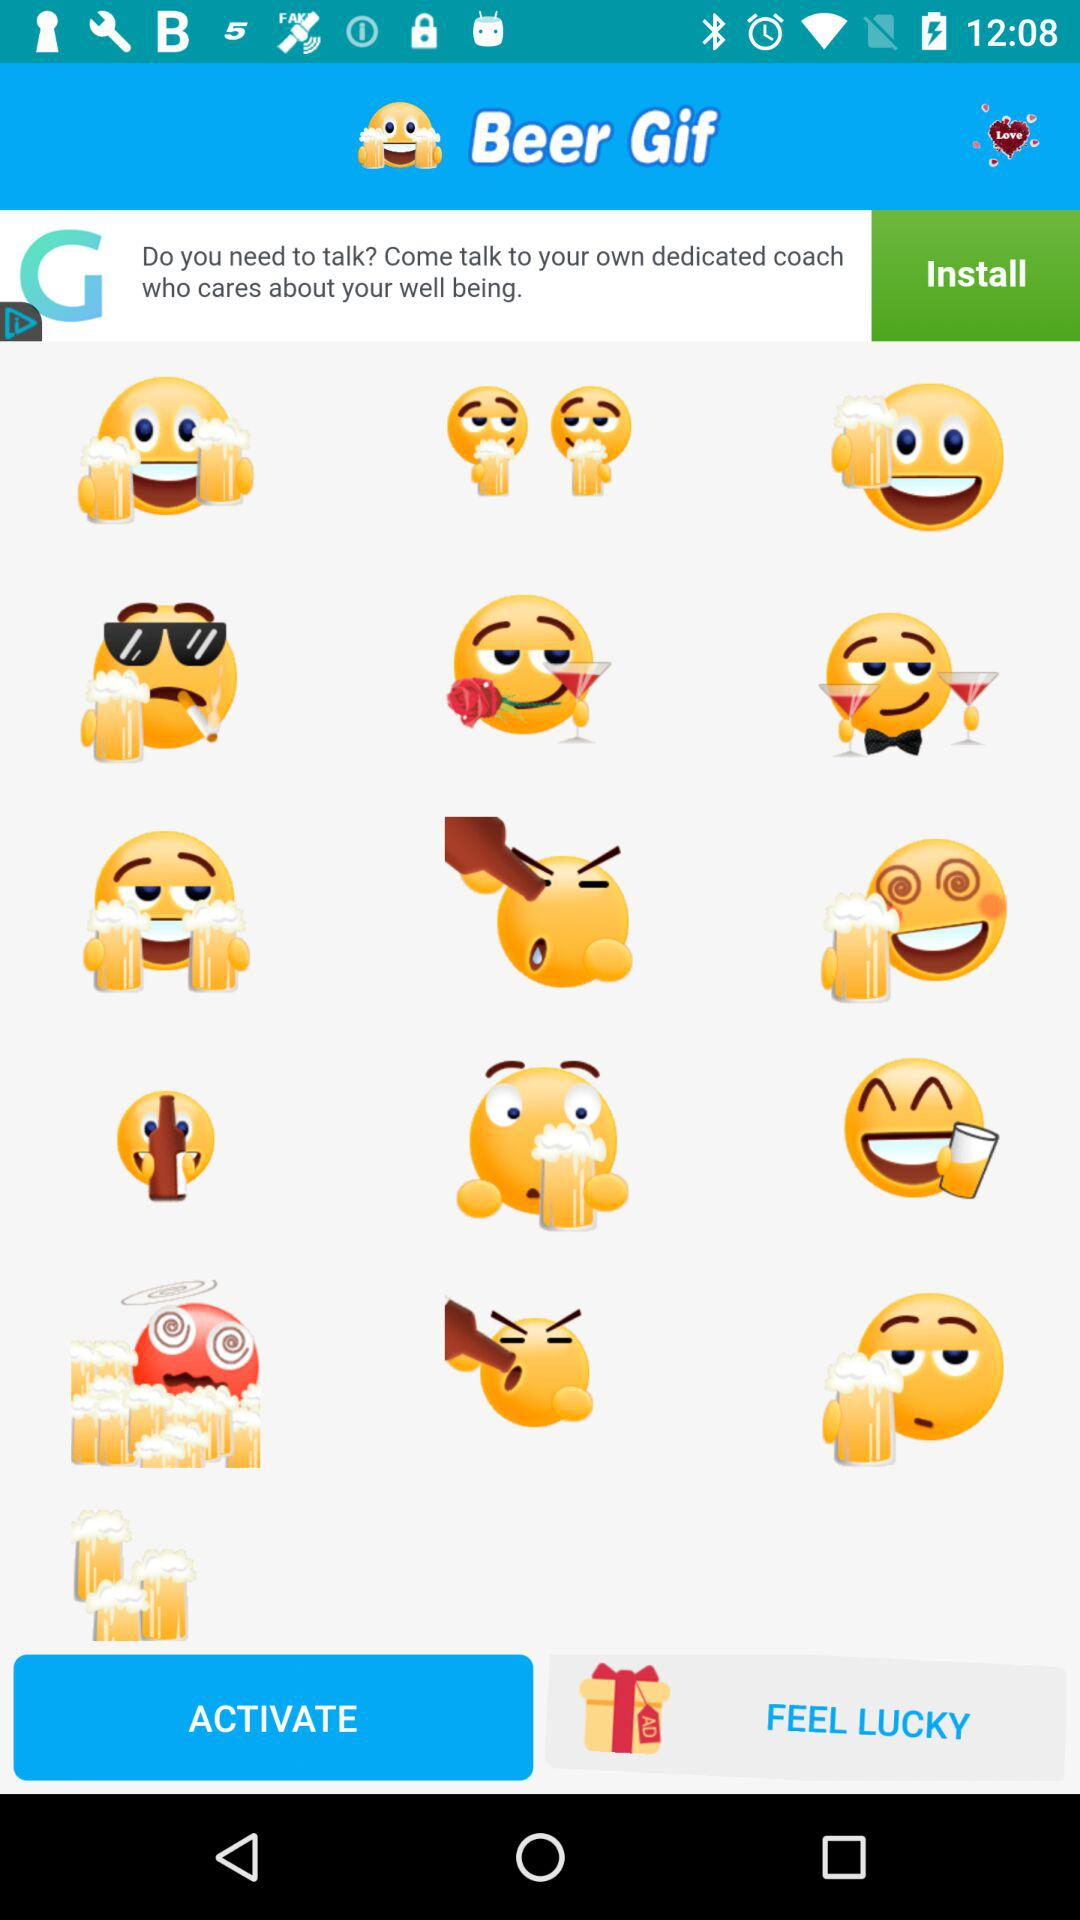What is the application name? The application name is "Beer Gif". 